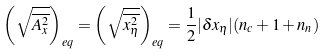<formula> <loc_0><loc_0><loc_500><loc_500>\left ( { \sqrt { \overline { A _ { x } ^ { 2 } } } } \right ) _ { e q } = \left ( { \sqrt { \overline { x _ { \eta } ^ { 2 } } } } \right ) _ { e q } = \frac { 1 } { 2 } | \delta x _ { \eta } | ( n _ { c } + 1 + n _ { n } )</formula> 